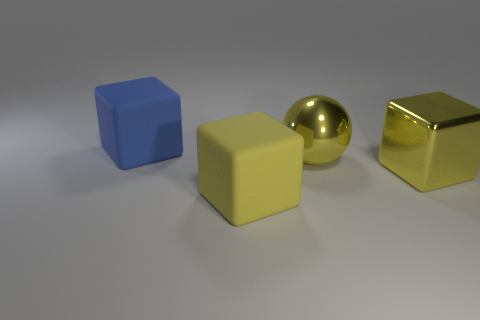Is the number of large objects that are on the right side of the big blue block greater than the number of tiny red cylinders?
Provide a succinct answer. Yes. There is a rubber object in front of the large metal ball; is its color the same as the cube that is right of the large yellow sphere?
Offer a very short reply. Yes. What material is the big yellow cube that is on the right side of the matte thing to the right of the large matte thing behind the yellow shiny block?
Provide a succinct answer. Metal. Are there more blue things than large matte cubes?
Keep it short and to the point. No. Is there anything else that is the same color as the big metallic cube?
Provide a short and direct response. Yes. There is a yellow object that is the same material as the blue cube; what is its size?
Keep it short and to the point. Large. What is the yellow ball made of?
Your response must be concise. Metal. What number of yellow blocks are the same size as the yellow metallic sphere?
Make the answer very short. 2. The big rubber thing that is the same color as the big ball is what shape?
Offer a very short reply. Cube. Is there another big yellow thing that has the same shape as the yellow matte object?
Provide a short and direct response. Yes. 